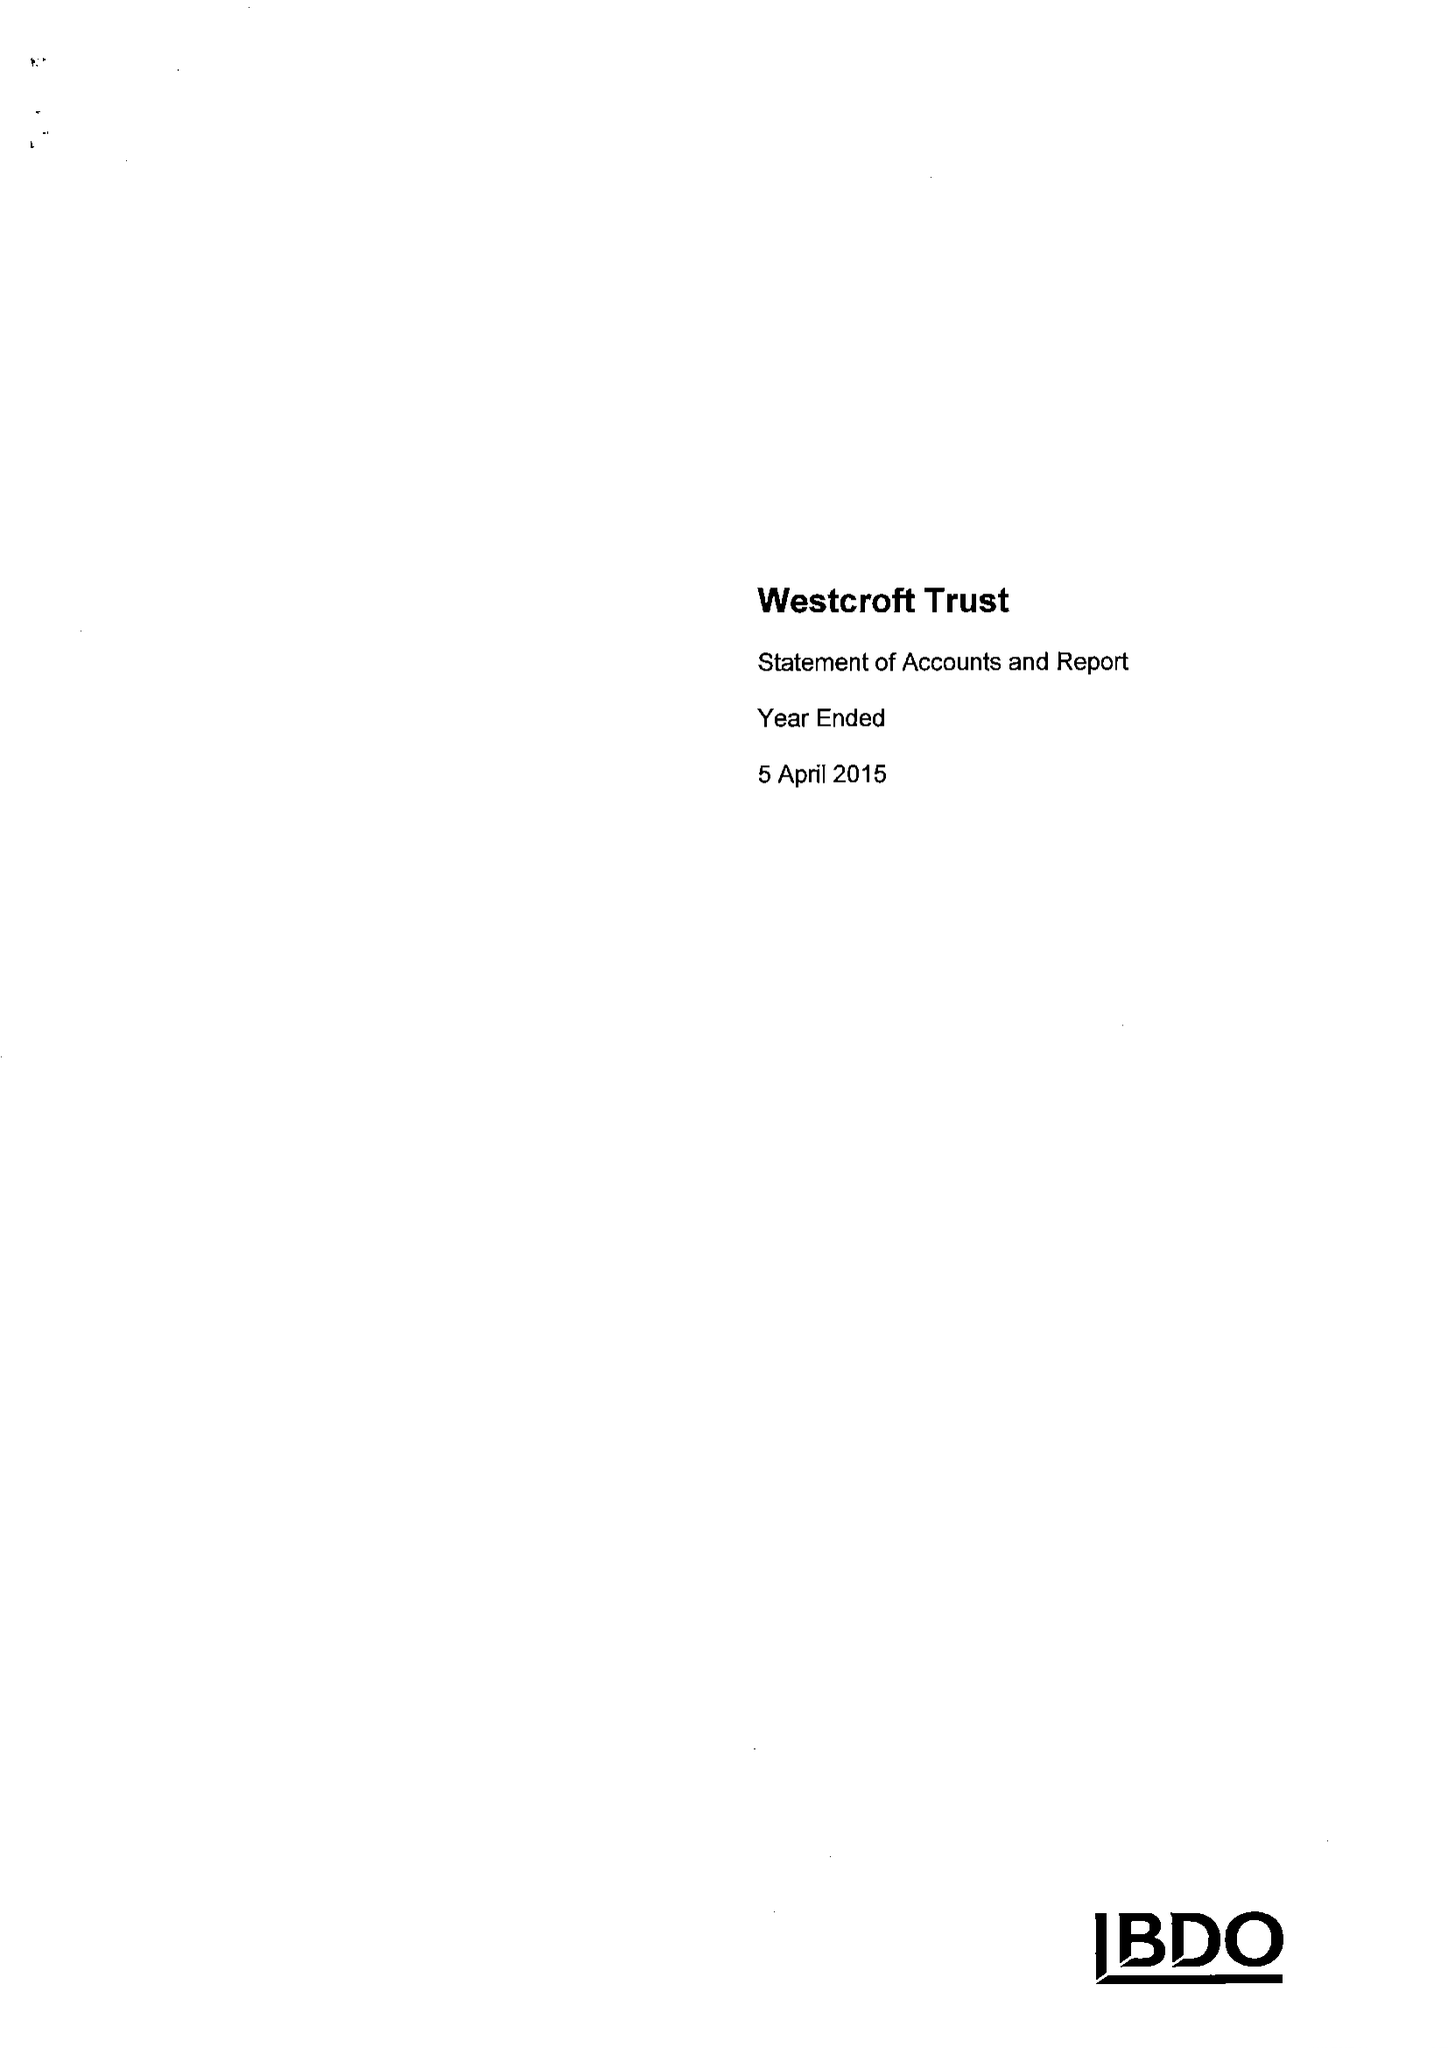What is the value for the spending_annually_in_british_pounds?
Answer the question using a single word or phrase. 134578.00 